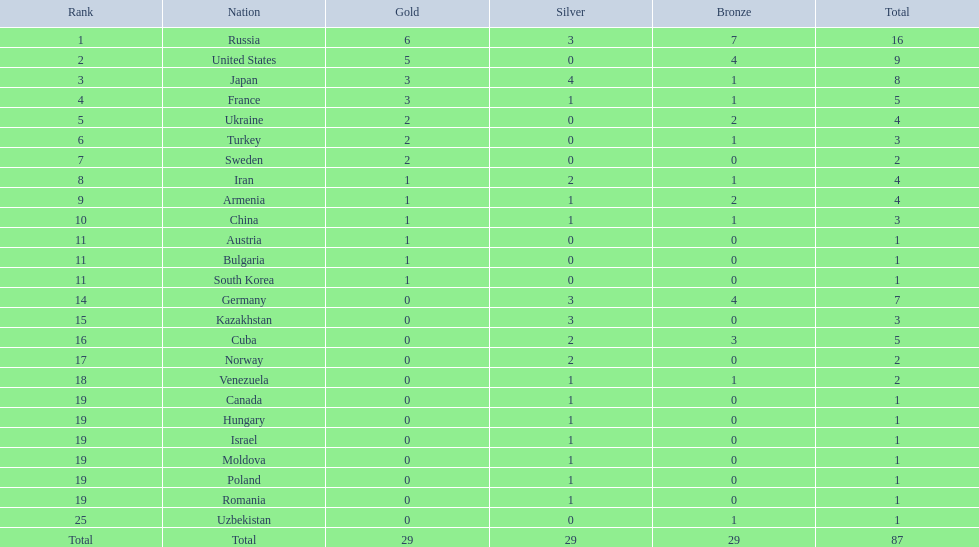In the 1995 world wrestling championships, which countries were involved? Russia, United States, Japan, France, Ukraine, Turkey, Sweden, Iran, Armenia, China, Austria, Bulgaria, South Korea, Germany, Kazakhstan, Cuba, Norway, Venezuela, Canada, Hungary, Israel, Moldova, Poland, Romania, Uzbekistan. Which nation claimed only one medal? Austria, Bulgaria, South Korea, Canada, Hungary, Israel, Moldova, Poland, Romania, Uzbekistan. From these, who won a bronze medal? Uzbekistan. 